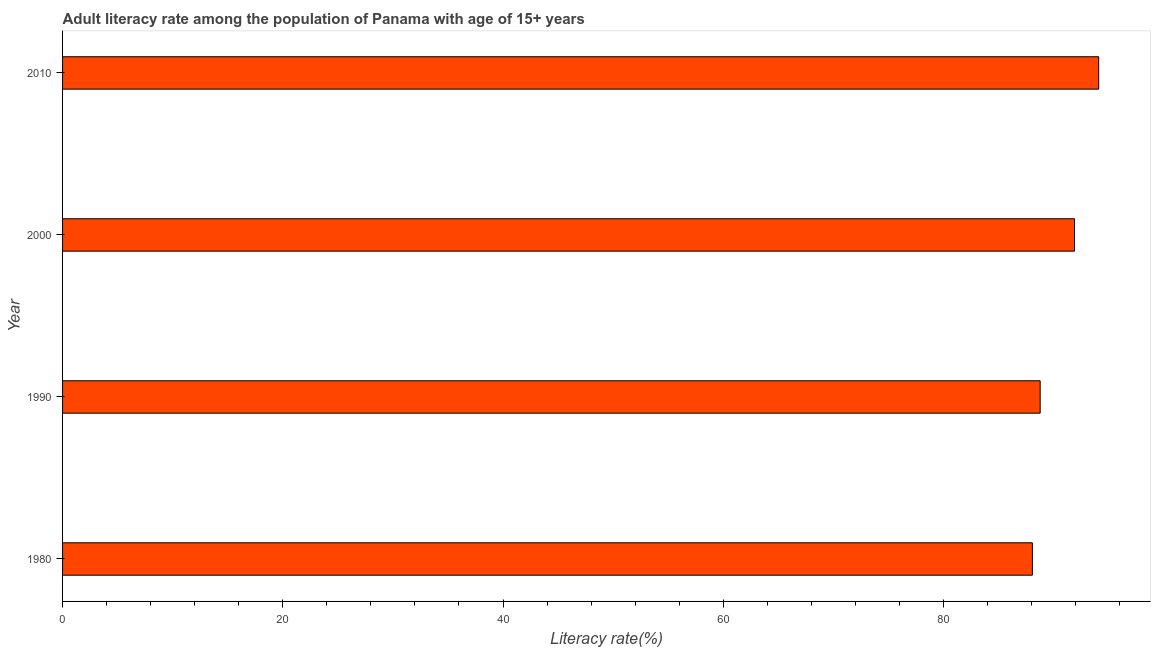Does the graph contain any zero values?
Keep it short and to the point. No. What is the title of the graph?
Keep it short and to the point. Adult literacy rate among the population of Panama with age of 15+ years. What is the label or title of the X-axis?
Your answer should be very brief. Literacy rate(%). What is the label or title of the Y-axis?
Offer a terse response. Year. What is the adult literacy rate in 1990?
Make the answer very short. 88.78. Across all years, what is the maximum adult literacy rate?
Your answer should be very brief. 94.09. Across all years, what is the minimum adult literacy rate?
Your answer should be very brief. 88.07. In which year was the adult literacy rate maximum?
Offer a terse response. 2010. What is the sum of the adult literacy rate?
Offer a very short reply. 362.85. What is the difference between the adult literacy rate in 2000 and 2010?
Keep it short and to the point. -2.19. What is the average adult literacy rate per year?
Provide a short and direct response. 90.71. What is the median adult literacy rate?
Give a very brief answer. 90.34. Do a majority of the years between 1990 and 1980 (inclusive) have adult literacy rate greater than 4 %?
Offer a terse response. No. Is the adult literacy rate in 1990 less than that in 2010?
Offer a terse response. Yes. What is the difference between the highest and the second highest adult literacy rate?
Provide a short and direct response. 2.19. Is the sum of the adult literacy rate in 1980 and 2000 greater than the maximum adult literacy rate across all years?
Your answer should be compact. Yes. What is the difference between the highest and the lowest adult literacy rate?
Offer a very short reply. 6.02. How many years are there in the graph?
Offer a very short reply. 4. What is the Literacy rate(%) in 1980?
Keep it short and to the point. 88.07. What is the Literacy rate(%) of 1990?
Offer a terse response. 88.78. What is the Literacy rate(%) in 2000?
Provide a short and direct response. 91.9. What is the Literacy rate(%) of 2010?
Provide a short and direct response. 94.09. What is the difference between the Literacy rate(%) in 1980 and 1990?
Give a very brief answer. -0.71. What is the difference between the Literacy rate(%) in 1980 and 2000?
Keep it short and to the point. -3.83. What is the difference between the Literacy rate(%) in 1980 and 2010?
Keep it short and to the point. -6.02. What is the difference between the Literacy rate(%) in 1990 and 2000?
Offer a terse response. -3.12. What is the difference between the Literacy rate(%) in 1990 and 2010?
Provide a succinct answer. -5.31. What is the difference between the Literacy rate(%) in 2000 and 2010?
Provide a short and direct response. -2.19. What is the ratio of the Literacy rate(%) in 1980 to that in 1990?
Offer a terse response. 0.99. What is the ratio of the Literacy rate(%) in 1980 to that in 2000?
Ensure brevity in your answer.  0.96. What is the ratio of the Literacy rate(%) in 1980 to that in 2010?
Offer a terse response. 0.94. What is the ratio of the Literacy rate(%) in 1990 to that in 2010?
Provide a succinct answer. 0.94. What is the ratio of the Literacy rate(%) in 2000 to that in 2010?
Offer a very short reply. 0.98. 